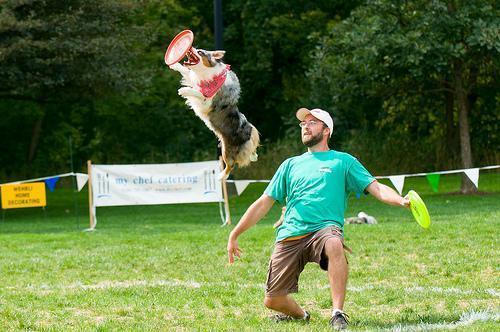How many Frisbees are in the picture?
Give a very brief answer. 2. 